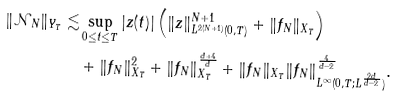<formula> <loc_0><loc_0><loc_500><loc_500>\| \mathcal { N } _ { N } \| _ { Y _ { T } } \lesssim & \sup _ { 0 \leq t \leq T } | z ( t ) | \left ( \| z \| _ { L ^ { 2 ( N + 1 ) } ( 0 , T ) } ^ { N + 1 } + \| f _ { N } \| _ { X _ { T } } \right ) \\ & + \| f _ { N } \| _ { X _ { T } } ^ { 2 } + \| f _ { N } \| _ { X _ { T } } ^ { \frac { d + 4 } { d } } + \| f _ { N } \| _ { X _ { T } } \| f _ { N } \| _ { L ^ { \infty } ( 0 , T ; L ^ { \frac { 2 d } { d - 2 } } ) } ^ { \frac { 4 } { d - 2 } } .</formula> 